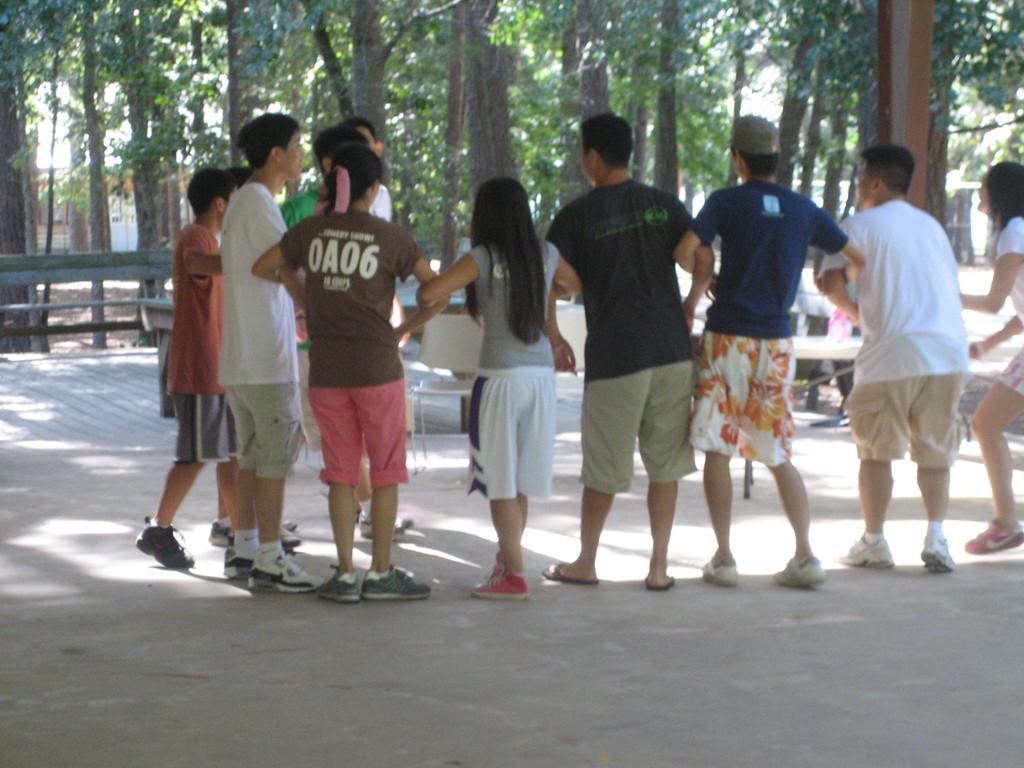How many people can be seen in the image? There are many people standing in the image. What is located at the bottom of the image? There is a road at the bottom of the image. What can be found in the background of the image? There are benches and trees in the background of the image. What type of sugar is being used for the activity in the image? There is no activity involving sugar present in the image. 